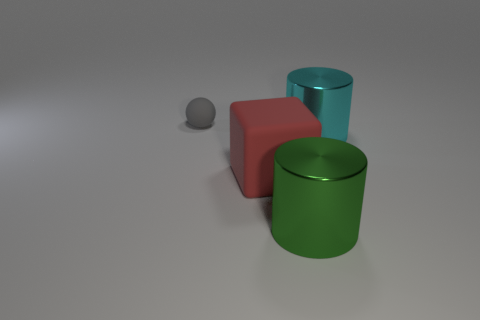Are there any other things that have the same size as the sphere?
Make the answer very short. No. There is a big matte object; is it the same shape as the matte object to the left of the rubber block?
Make the answer very short. No. There is a large cylinder behind the cylinder that is on the left side of the large thing that is right of the green cylinder; what is its color?
Offer a terse response. Cyan. How many objects are either metal things behind the red object or cylinders that are behind the rubber cube?
Offer a very short reply. 1. What number of other things are there of the same color as the small matte ball?
Keep it short and to the point. 0. There is a rubber object in front of the small gray matte sphere; is its shape the same as the gray matte object?
Your answer should be very brief. No. Is the number of big red cubes that are to the left of the ball less than the number of large red matte cylinders?
Provide a succinct answer. No. Is there a green cylinder that has the same material as the cyan cylinder?
Your response must be concise. Yes. There is a block that is the same size as the cyan metal object; what is it made of?
Offer a terse response. Rubber. Are there fewer big rubber things in front of the big red matte cube than red blocks that are in front of the large cyan metal cylinder?
Offer a terse response. Yes. 